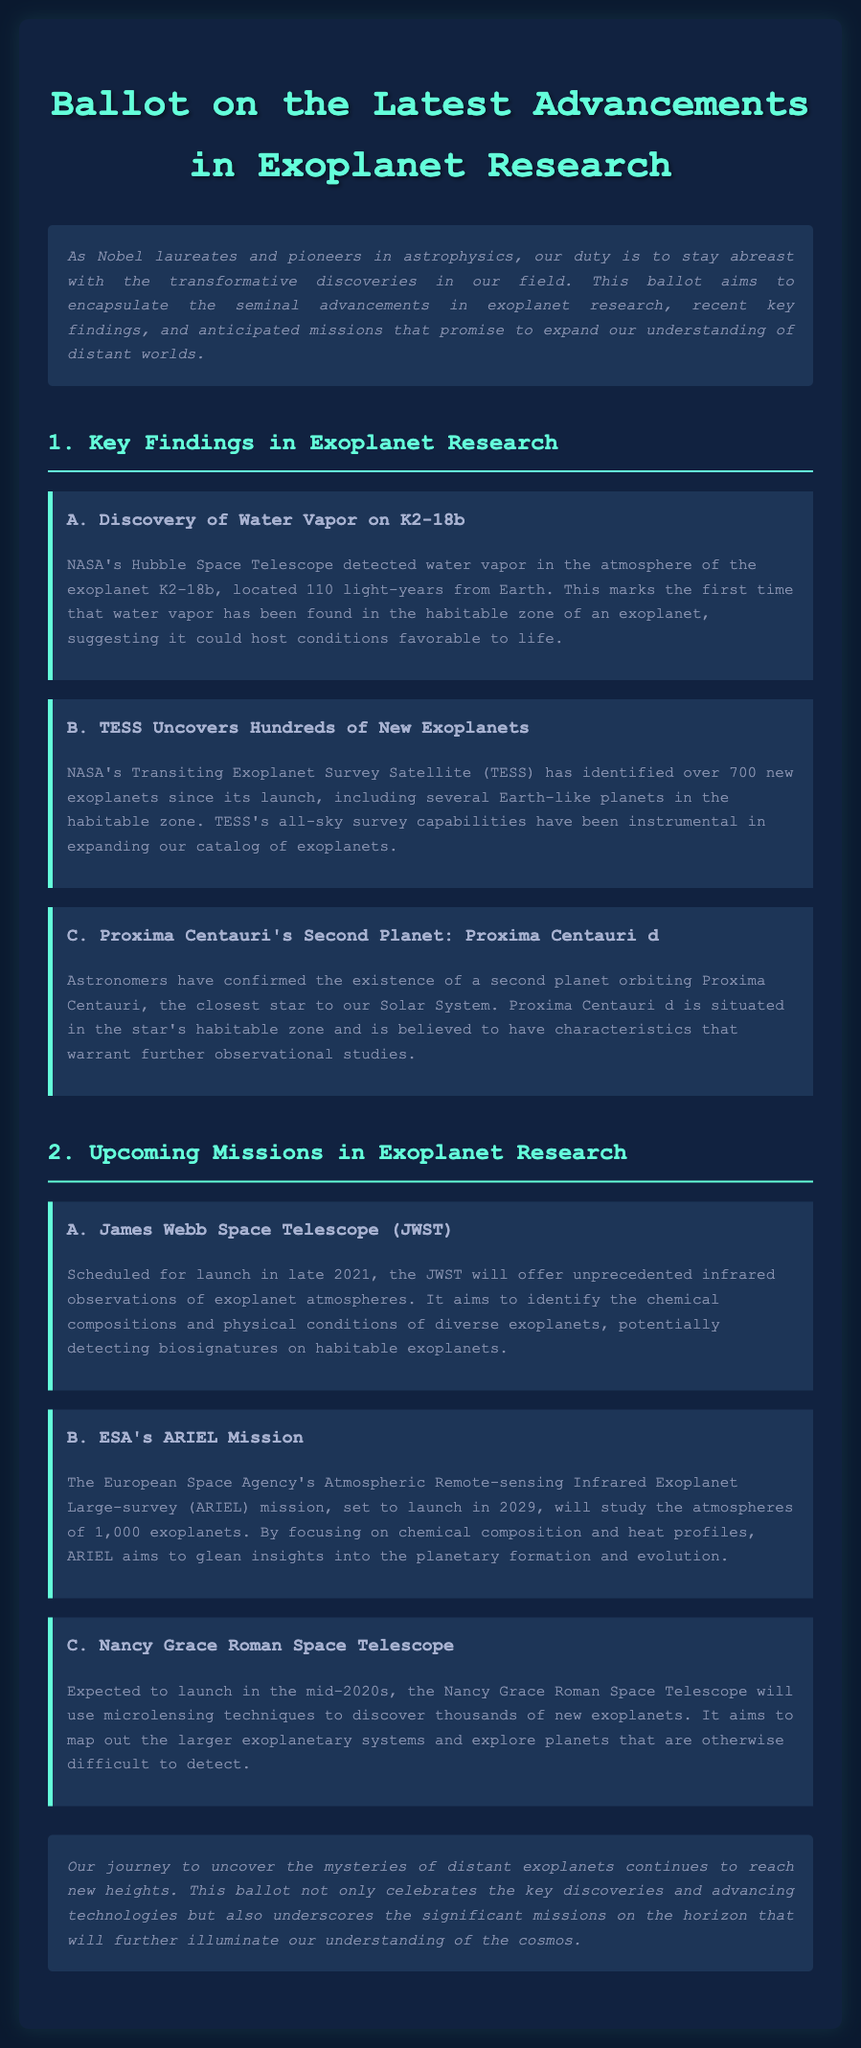What is the name of the exoplanet with detected water vapor? NASA's Hubble Space Telescope detected water vapor in the atmosphere of the exoplanet K2-18b.
Answer: K2-18b How many new exoplanets has TESS identified? NASA's Transiting Exoplanet Survey Satellite (TESS) has identified over 700 new exoplanets since its launch.
Answer: Over 700 What is the launch year for ESA's ARIEL Mission? The European Space Agency's ARIEL Mission is set to launch in 2029.
Answer: 2029 What is the main goal of the James Webb Space Telescope (JWST)? JWST aims to offer unprecedented infrared observations of exoplanet atmospheres and potentially detecting biosignatures on habitable exoplanets.
Answer: Detect biosignatures How many exoplanets will the ARIEL Mission study? ARIEL aims to study the atmospheres of 1,000 exoplanets.
Answer: 1,000 What characteristic makes Proxima Centauri d notable? Proxima Centauri d is located in the star's habitable zone and is believed to warrant further observational studies.
Answer: Habitable zone What technique will the Nancy Grace Roman Space Telescope use to discover exoplanets? It will use microlensing techniques to discover thousands of new exoplanets.
Answer: Microlensing What type of document is this? The document encapsulates advancements in exoplanet research, recent key findings, and anticipated missions.
Answer: Ballot 